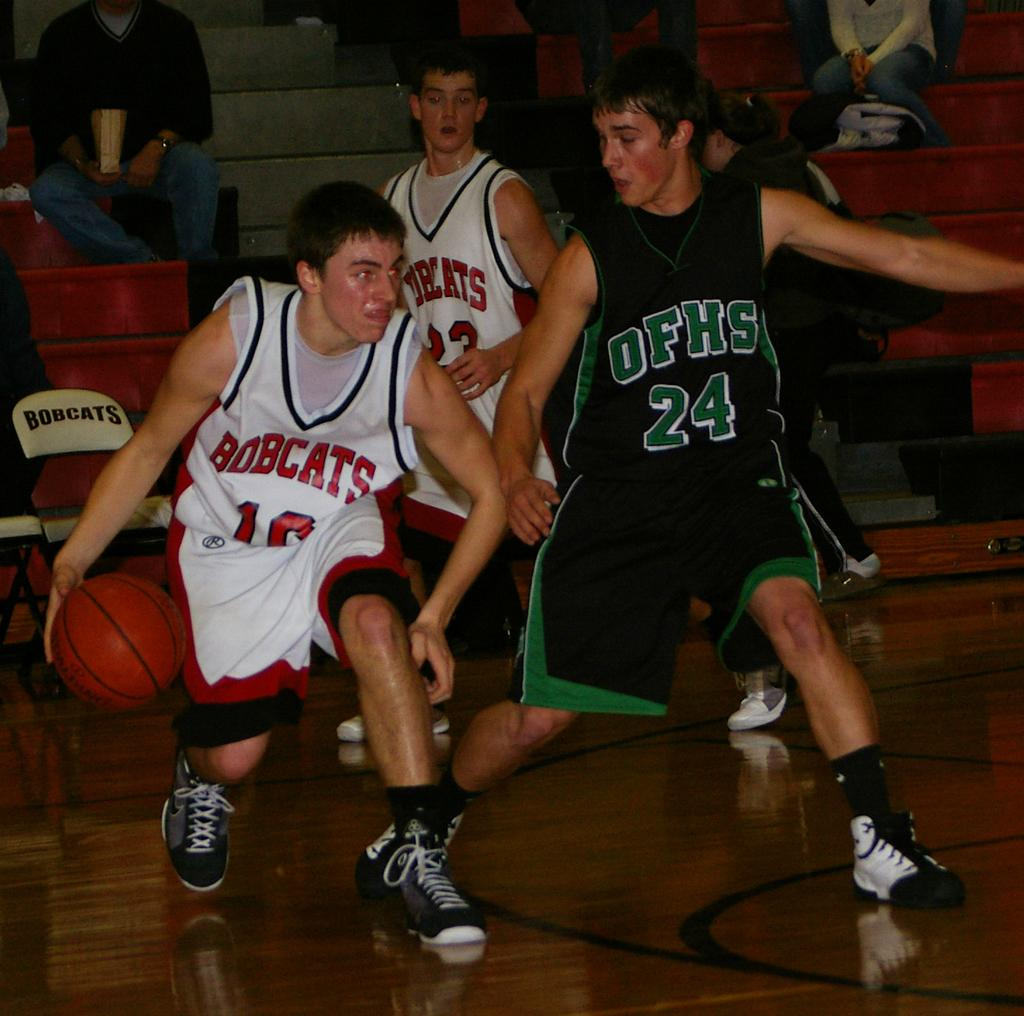<image>
Offer a succinct explanation of the picture presented. Number 24 of OFHS plays defense against the Bobcats team. 